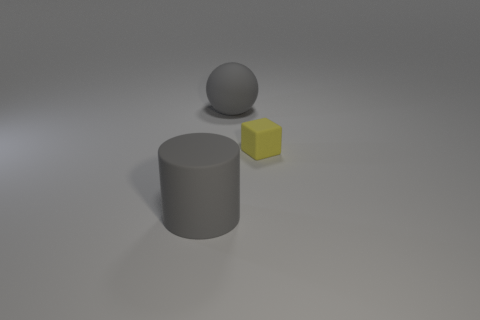Add 1 gray metallic balls. How many objects exist? 4 Subtract all cylinders. How many objects are left? 2 Subtract 0 green balls. How many objects are left? 3 Subtract all blue rubber cylinders. Subtract all small yellow cubes. How many objects are left? 2 Add 1 small matte cubes. How many small matte cubes are left? 2 Add 3 large brown metallic cubes. How many large brown metallic cubes exist? 3 